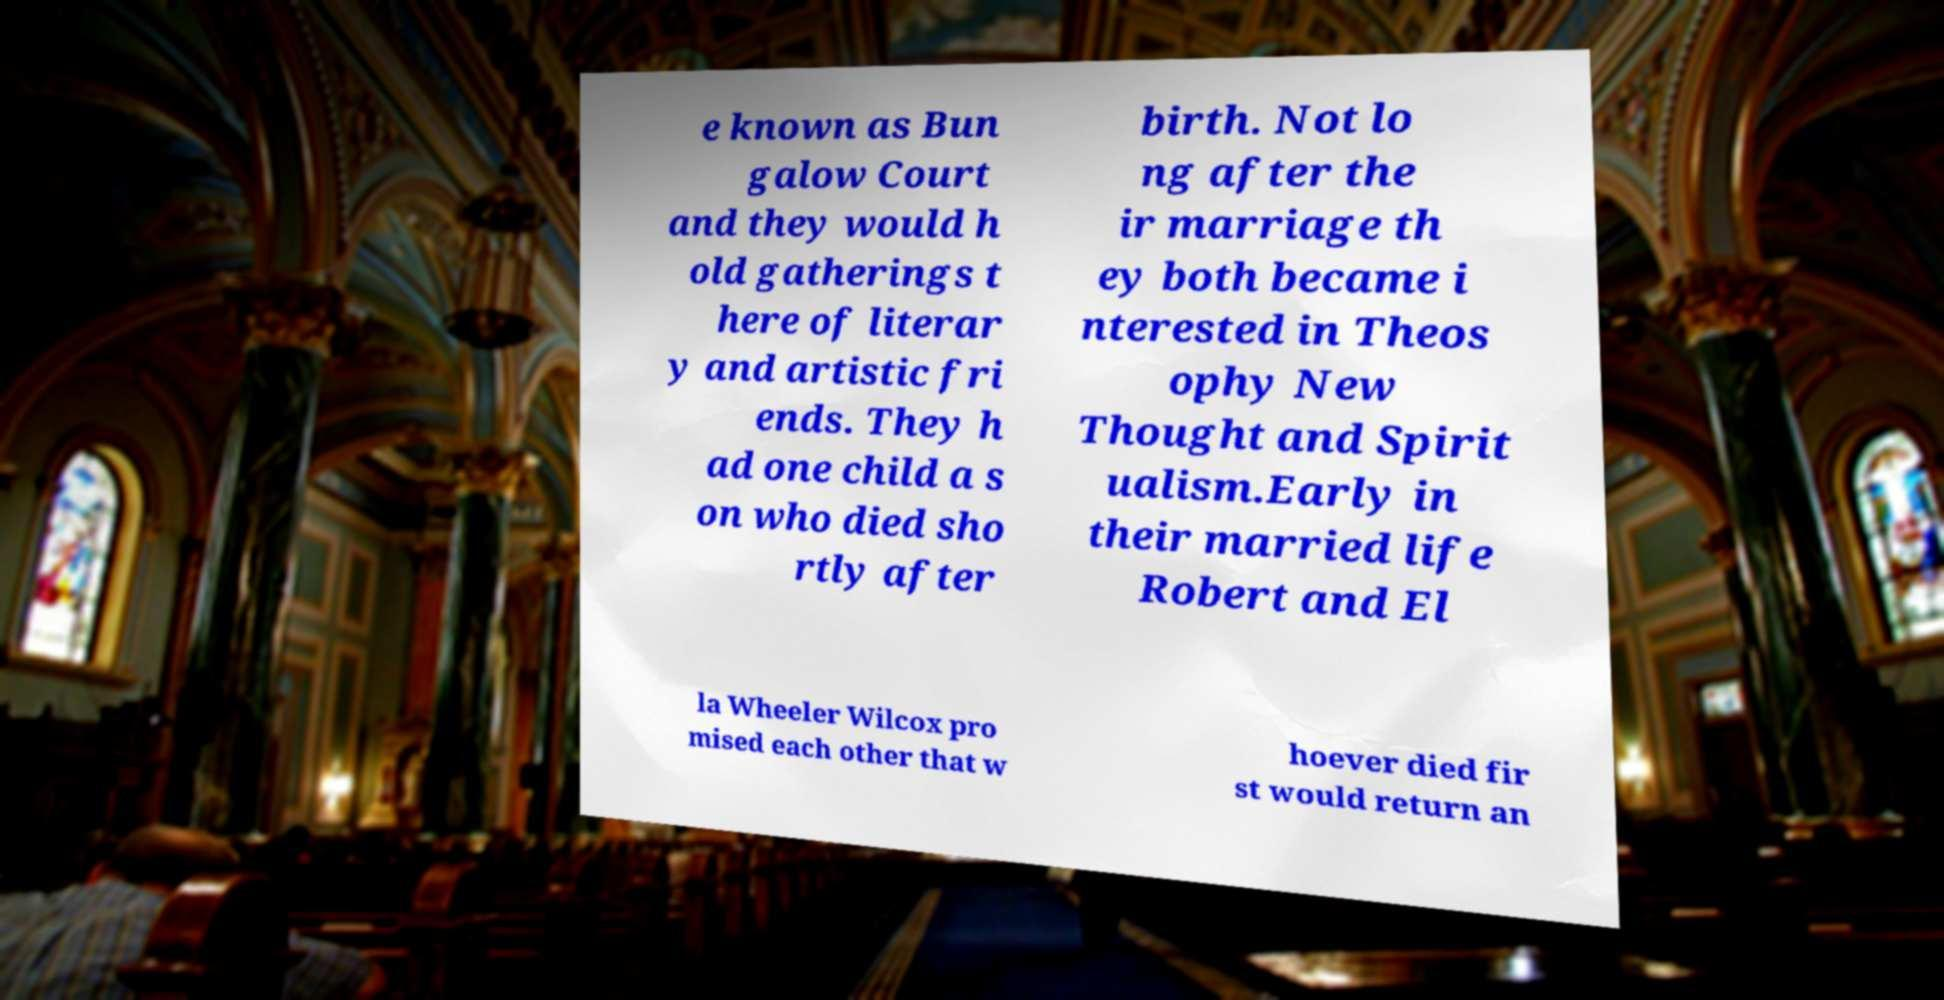Could you assist in decoding the text presented in this image and type it out clearly? e known as Bun galow Court and they would h old gatherings t here of literar y and artistic fri ends. They h ad one child a s on who died sho rtly after birth. Not lo ng after the ir marriage th ey both became i nterested in Theos ophy New Thought and Spirit ualism.Early in their married life Robert and El la Wheeler Wilcox pro mised each other that w hoever died fir st would return an 